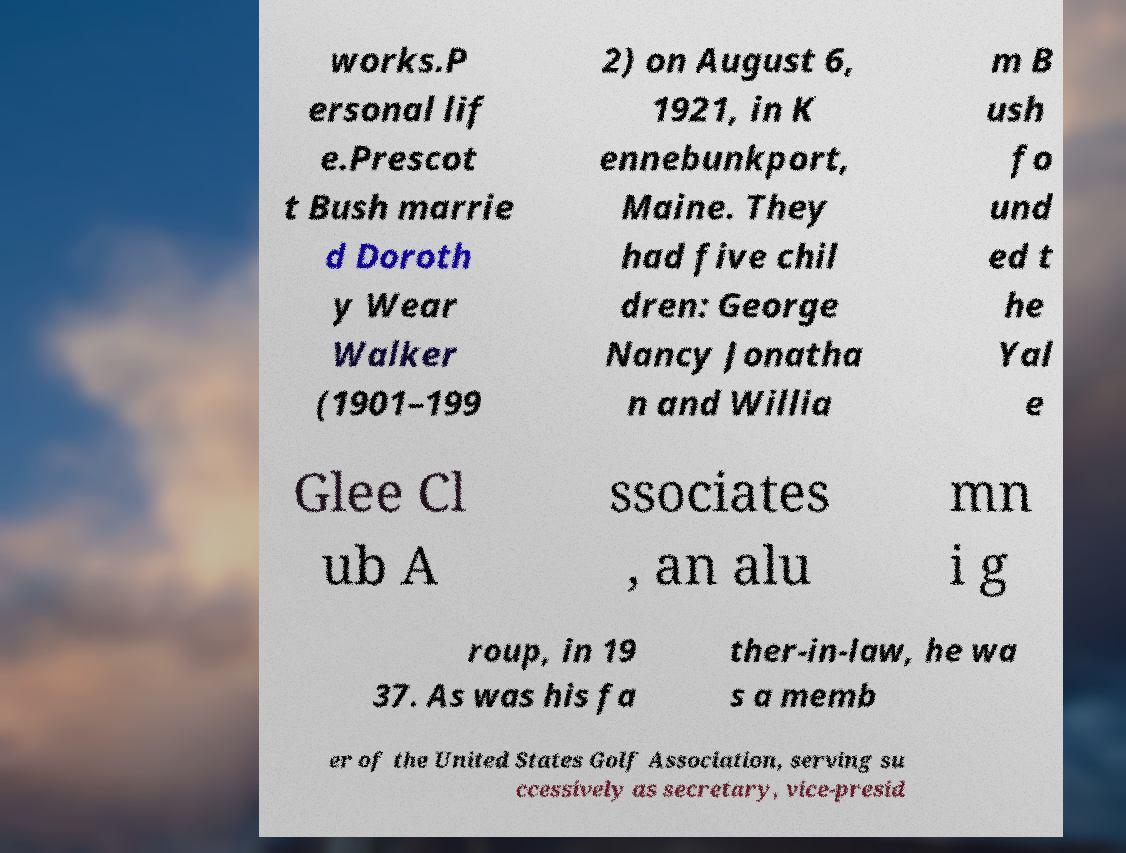Could you assist in decoding the text presented in this image and type it out clearly? works.P ersonal lif e.Prescot t Bush marrie d Doroth y Wear Walker (1901–199 2) on August 6, 1921, in K ennebunkport, Maine. They had five chil dren: George Nancy Jonatha n and Willia m B ush fo und ed t he Yal e Glee Cl ub A ssociates , an alu mn i g roup, in 19 37. As was his fa ther-in-law, he wa s a memb er of the United States Golf Association, serving su ccessively as secretary, vice-presid 